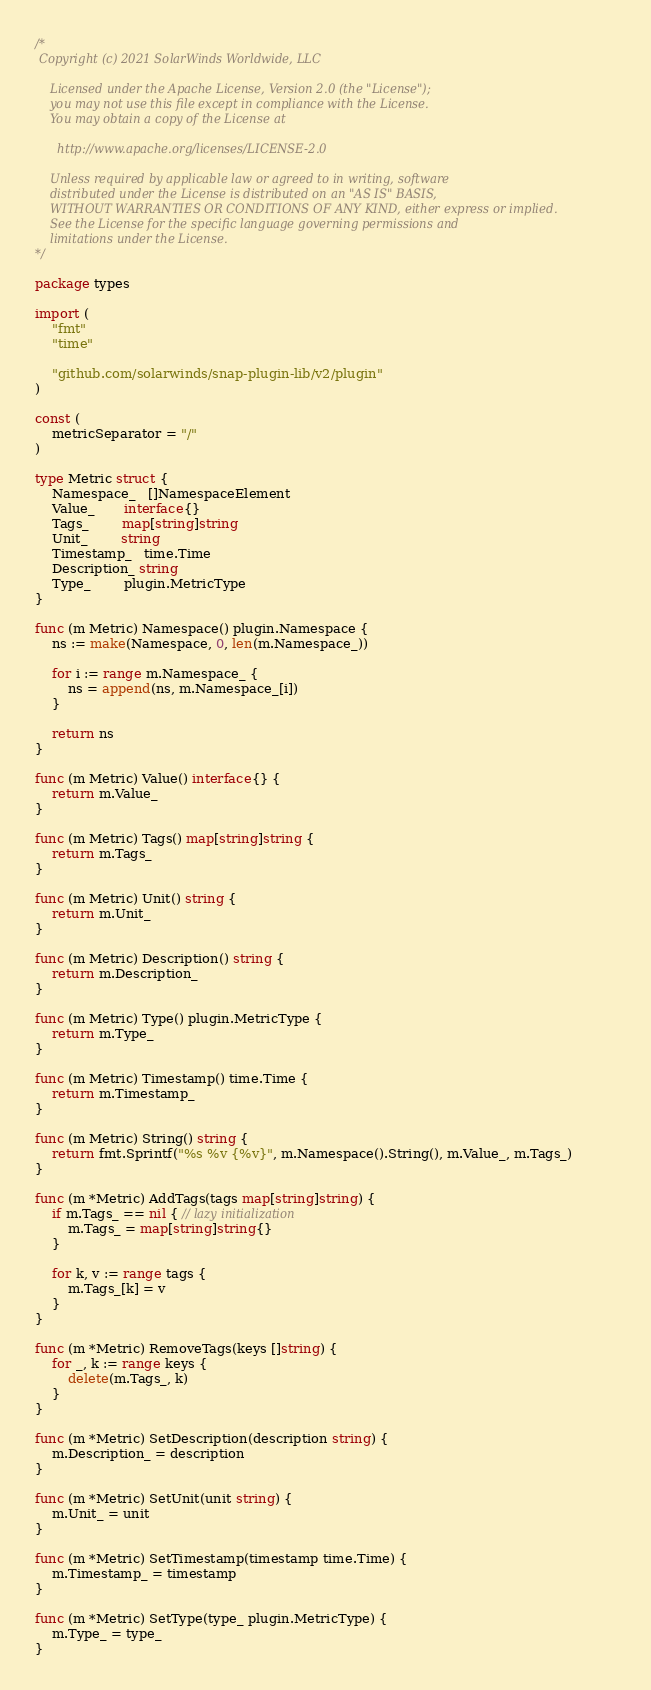<code> <loc_0><loc_0><loc_500><loc_500><_Go_>/*
 Copyright (c) 2021 SolarWinds Worldwide, LLC

    Licensed under the Apache License, Version 2.0 (the "License");
    you may not use this file except in compliance with the License.
    You may obtain a copy of the License at

      http://www.apache.org/licenses/LICENSE-2.0

    Unless required by applicable law or agreed to in writing, software
    distributed under the License is distributed on an "AS IS" BASIS,
    WITHOUT WARRANTIES OR CONDITIONS OF ANY KIND, either express or implied.
    See the License for the specific language governing permissions and
    limitations under the License.
*/

package types

import (
	"fmt"
	"time"

	"github.com/solarwinds/snap-plugin-lib/v2/plugin"
)

const (
	metricSeparator = "/"
)

type Metric struct {
	Namespace_   []NamespaceElement
	Value_       interface{}
	Tags_        map[string]string
	Unit_        string
	Timestamp_   time.Time
	Description_ string
	Type_        plugin.MetricType
}

func (m Metric) Namespace() plugin.Namespace {
	ns := make(Namespace, 0, len(m.Namespace_))

	for i := range m.Namespace_ {
		ns = append(ns, m.Namespace_[i])
	}

	return ns
}

func (m Metric) Value() interface{} {
	return m.Value_
}

func (m Metric) Tags() map[string]string {
	return m.Tags_
}

func (m Metric) Unit() string {
	return m.Unit_
}

func (m Metric) Description() string {
	return m.Description_
}

func (m Metric) Type() plugin.MetricType {
	return m.Type_
}

func (m Metric) Timestamp() time.Time {
	return m.Timestamp_
}

func (m Metric) String() string {
	return fmt.Sprintf("%s %v {%v}", m.Namespace().String(), m.Value_, m.Tags_)
}

func (m *Metric) AddTags(tags map[string]string) {
	if m.Tags_ == nil { // lazy initialization
		m.Tags_ = map[string]string{}
	}

	for k, v := range tags {
		m.Tags_[k] = v
	}
}

func (m *Metric) RemoveTags(keys []string) {
	for _, k := range keys {
		delete(m.Tags_, k)
	}
}

func (m *Metric) SetDescription(description string) {
	m.Description_ = description
}

func (m *Metric) SetUnit(unit string) {
	m.Unit_ = unit
}

func (m *Metric) SetTimestamp(timestamp time.Time) {
	m.Timestamp_ = timestamp
}

func (m *Metric) SetType(type_ plugin.MetricType) {
	m.Type_ = type_
}
</code> 